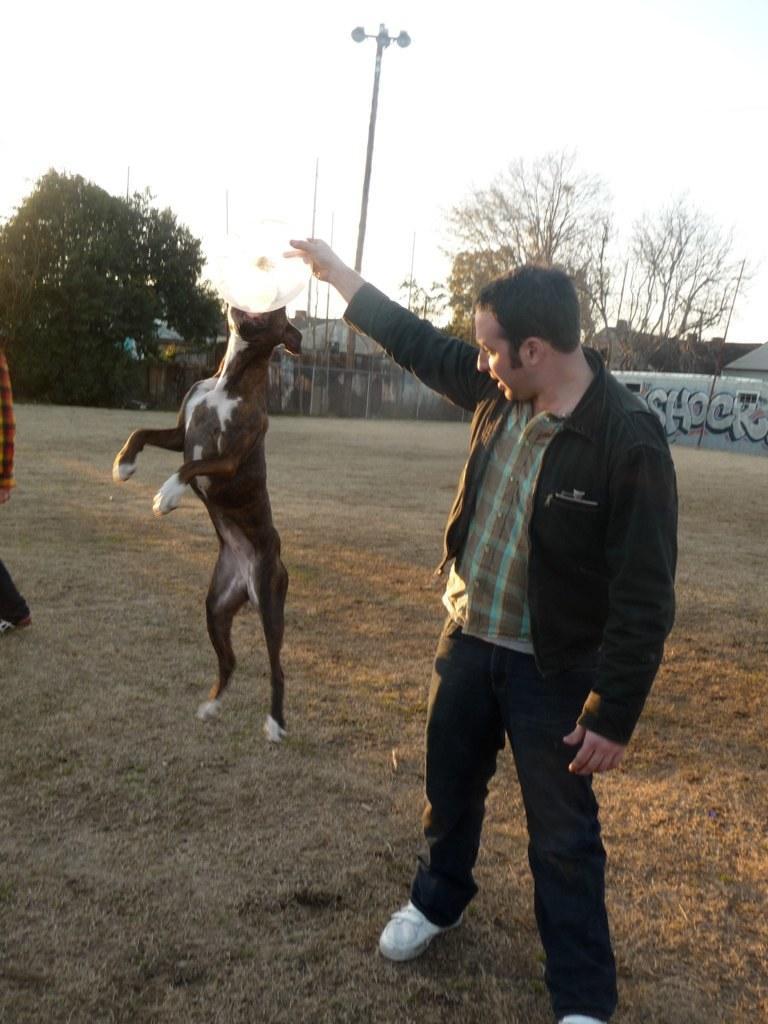Please provide a concise description of this image. There is a man standing and holding a white color object, we can see a dog. In the background we can see painting on a wall, trees, poles, lights on pole and sky. On the left side of the image we can see a person. 